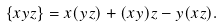Convert formula to latex. <formula><loc_0><loc_0><loc_500><loc_500>\{ x y z \} = x ( y z ) + ( x y ) z - y ( x z ) .</formula> 